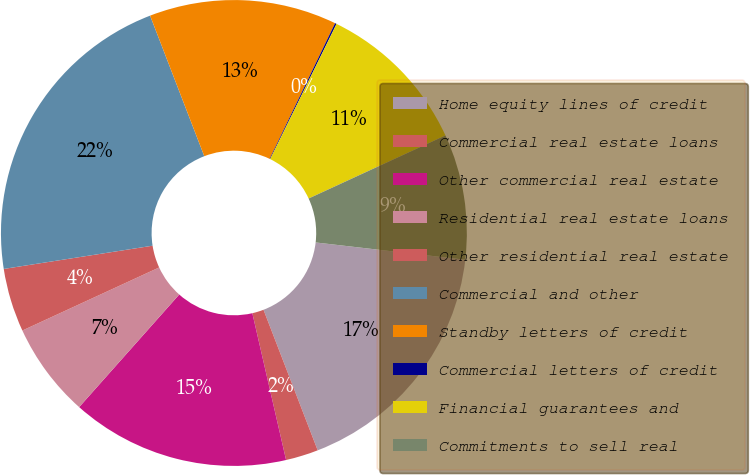Convert chart. <chart><loc_0><loc_0><loc_500><loc_500><pie_chart><fcel>Home equity lines of credit<fcel>Commercial real estate loans<fcel>Other commercial real estate<fcel>Residential real estate loans<fcel>Other residential real estate<fcel>Commercial and other<fcel>Standby letters of credit<fcel>Commercial letters of credit<fcel>Financial guarantees and<fcel>Commitments to sell real<nl><fcel>17.31%<fcel>2.26%<fcel>15.16%<fcel>6.56%<fcel>4.41%<fcel>21.61%<fcel>13.01%<fcel>0.11%<fcel>10.86%<fcel>8.71%<nl></chart> 